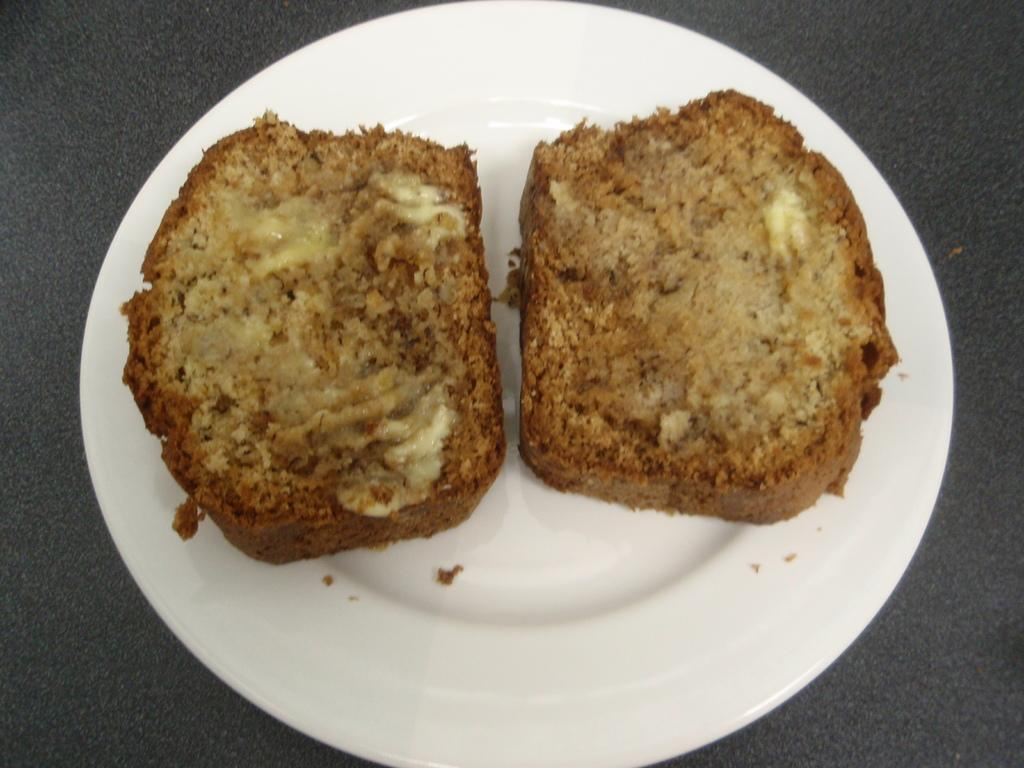What is on the plate that is visible in the image? There is food in a plate in the image. Where is the plate located in the image? The plate is placed on a table. What condition is the doll in while sitting on the table in the image? There is no doll present in the image; it only features a plate of food on a table. 